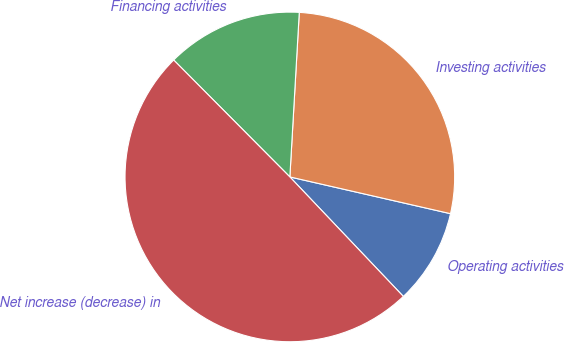<chart> <loc_0><loc_0><loc_500><loc_500><pie_chart><fcel>Operating activities<fcel>Investing activities<fcel>Financing activities<fcel>Net increase (decrease) in<nl><fcel>9.33%<fcel>27.67%<fcel>13.36%<fcel>49.64%<nl></chart> 